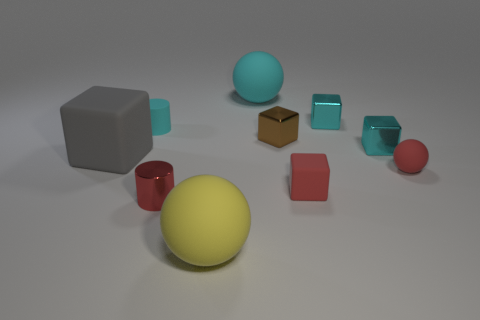Subtract 2 cubes. How many cubes are left? 3 Subtract all purple cubes. Subtract all yellow cylinders. How many cubes are left? 5 Subtract all spheres. How many objects are left? 7 Subtract all cyan cylinders. Subtract all big yellow matte balls. How many objects are left? 8 Add 6 gray matte blocks. How many gray matte blocks are left? 7 Add 8 large cyan rubber spheres. How many large cyan rubber spheres exist? 9 Subtract 1 red cubes. How many objects are left? 9 